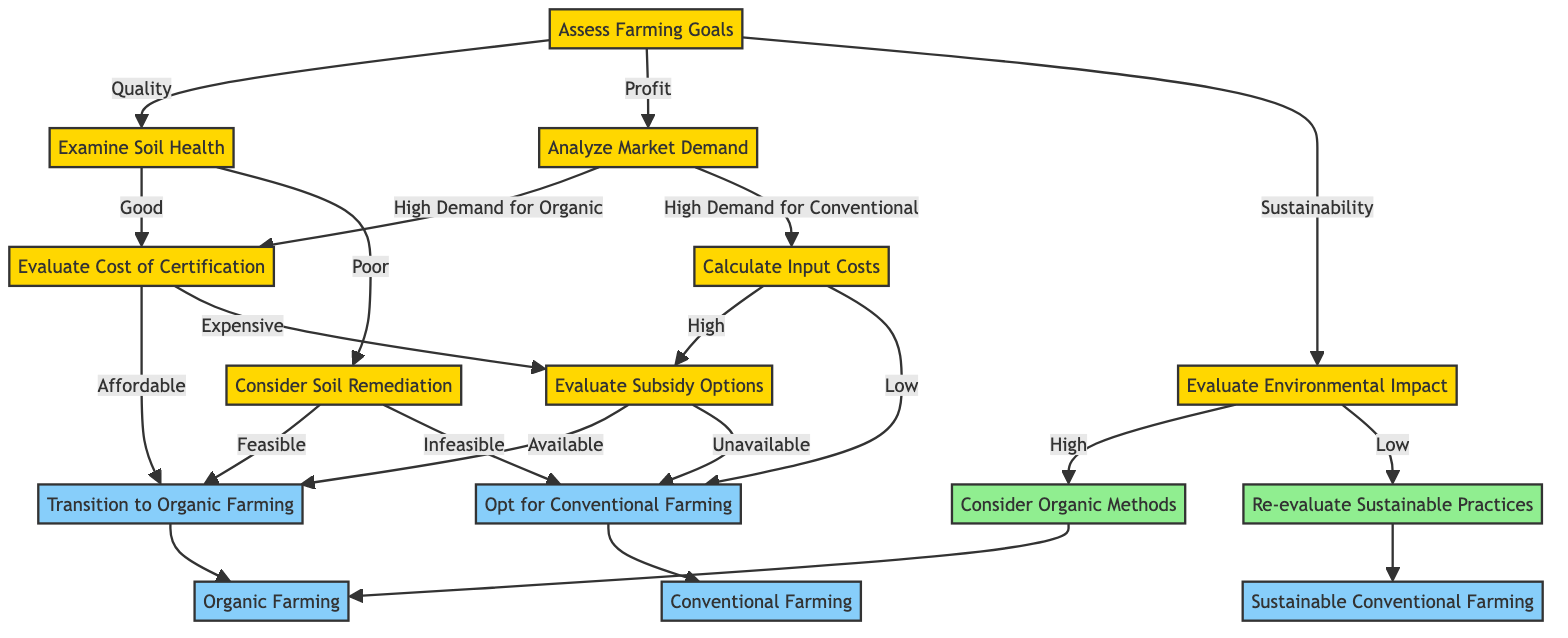What is the first step in the decision-making process? The first node in the diagram is "Assess Farming Goals," indicating that it is the starting point for the decision-making process.
Answer: Assess Farming Goals How many outcomes are possible from the "Evaluate Environmental Impact" decision? The node "Evaluate Environmental Impact" leads to two potential outcomes: "Consider Organic Methods" and "Re-evaluate Sustainable Practices," totaling two outcomes.
Answer: Two What are the conditions that lead to "Transition to Organic Farming"? The path to "Transition to Organic Farming" can be reached through three possible routes: "Evaluate Cost of Certification" being "Affordable," "Consider Soil Remediation" being "Feasible," or "Evaluate Environmental Impact" being "High."
Answer: Affordable, Feasible, High What result is reached if the cost of certification is expensive? If the "Evaluate Cost of Certification" leads to "Expensive," the next step is to "Evaluate Subsidy Options," which could lead to "Opt for Conventional Farming" if no subsidies are available.
Answer: Evaluate Subsidy Options What happens when the input costs are low after analyzing market demand? When "Analyze Market Demand" leads to "High Demand for Conventional," and if "Calculate Input Costs" determines the costs as "Low," the outcome will be "Opt for Conventional Farming."
Answer: Opt for Conventional Farming If soil health is poor and remediation is infeasible, what is the final decision? In this case, the flow begins with "Examine Soil Health," leading to "Consider Soil Remediation," which can lead to "Opt for Conventional Farming" if remediation is infeasible. Thus, the outcome is determined to be "Opt for Conventional Farming."
Answer: Opt for Conventional Farming What decision is made if there is a high environmental impact? The node "Evaluate Environmental Impact" leads to "Consider Organic Methods" if the environmental impact is classified as "High," which then results in transitioning to organic farming.
Answer: Organic Farming How many nodes are associated with assessing market demand? The assessment of market demand occurs at the node "Analyze Market Demand," leading to two options: "High Demand for Organic" or "High Demand for Conventional," thus having two associated nodes.
Answer: Two 